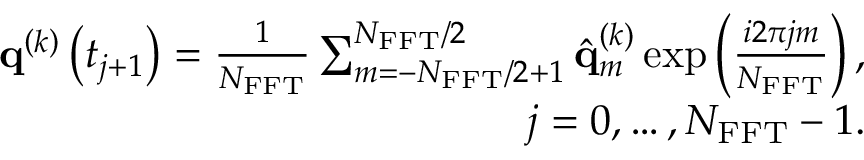<formula> <loc_0><loc_0><loc_500><loc_500>\begin{array} { r } { { q } ^ { \left ( k \right ) } \left ( t _ { j + 1 } \right ) = \frac { 1 } { N _ { F F T } } \sum _ { m = - N _ { F F T } / 2 + 1 } ^ { N _ { F F T } / 2 } \hat { q } _ { m } ^ { \left ( k \right ) } \exp \left ( { \frac { i 2 \pi j m } { N _ { F F T } } } \right ) , } \\ { j = 0 , \dots , N _ { F F T } - 1 . } \end{array}</formula> 